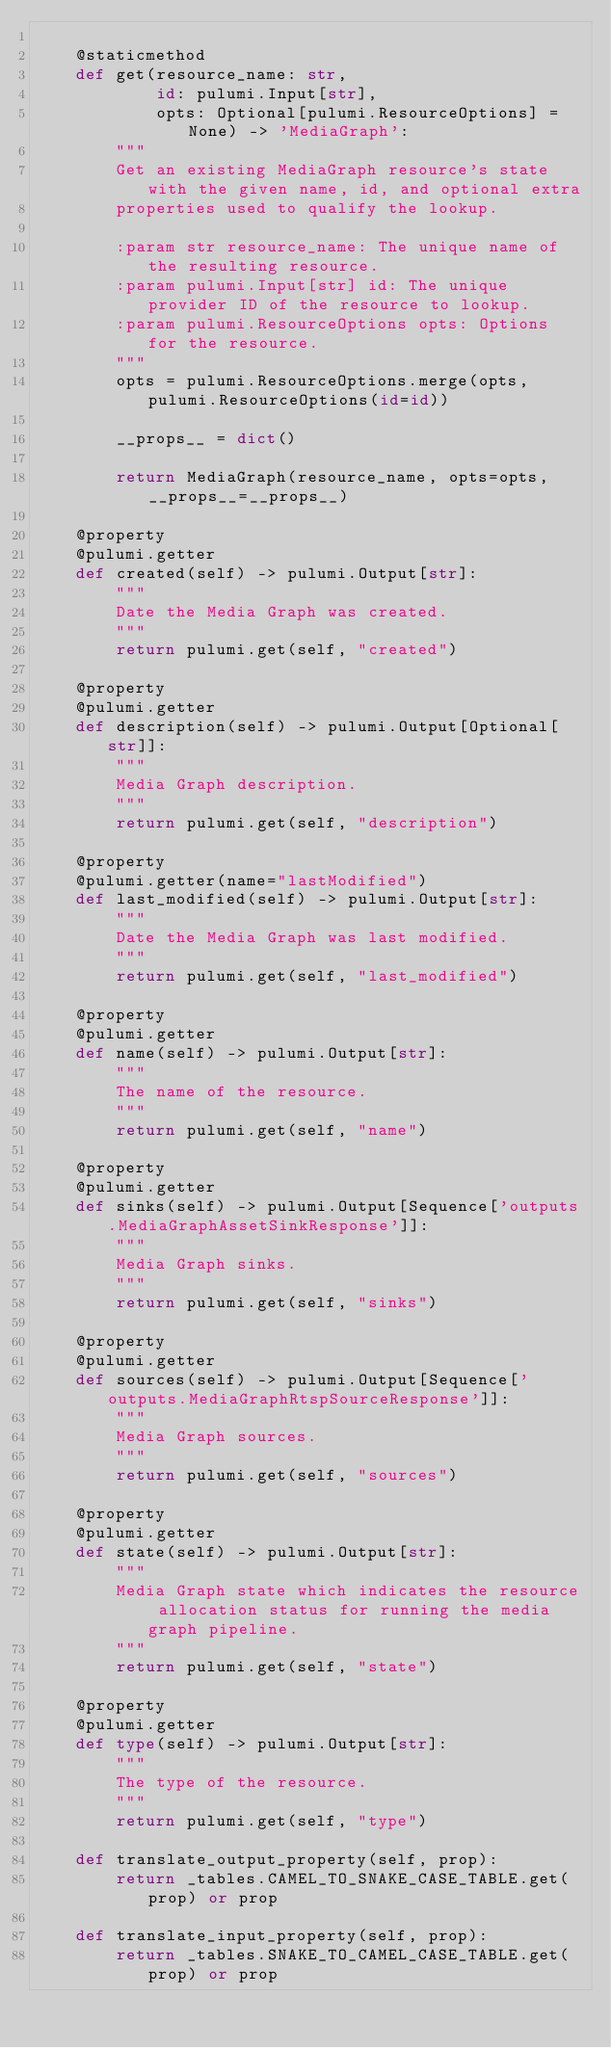Convert code to text. <code><loc_0><loc_0><loc_500><loc_500><_Python_>
    @staticmethod
    def get(resource_name: str,
            id: pulumi.Input[str],
            opts: Optional[pulumi.ResourceOptions] = None) -> 'MediaGraph':
        """
        Get an existing MediaGraph resource's state with the given name, id, and optional extra
        properties used to qualify the lookup.

        :param str resource_name: The unique name of the resulting resource.
        :param pulumi.Input[str] id: The unique provider ID of the resource to lookup.
        :param pulumi.ResourceOptions opts: Options for the resource.
        """
        opts = pulumi.ResourceOptions.merge(opts, pulumi.ResourceOptions(id=id))

        __props__ = dict()

        return MediaGraph(resource_name, opts=opts, __props__=__props__)

    @property
    @pulumi.getter
    def created(self) -> pulumi.Output[str]:
        """
        Date the Media Graph was created.
        """
        return pulumi.get(self, "created")

    @property
    @pulumi.getter
    def description(self) -> pulumi.Output[Optional[str]]:
        """
        Media Graph description.
        """
        return pulumi.get(self, "description")

    @property
    @pulumi.getter(name="lastModified")
    def last_modified(self) -> pulumi.Output[str]:
        """
        Date the Media Graph was last modified.
        """
        return pulumi.get(self, "last_modified")

    @property
    @pulumi.getter
    def name(self) -> pulumi.Output[str]:
        """
        The name of the resource.
        """
        return pulumi.get(self, "name")

    @property
    @pulumi.getter
    def sinks(self) -> pulumi.Output[Sequence['outputs.MediaGraphAssetSinkResponse']]:
        """
        Media Graph sinks.
        """
        return pulumi.get(self, "sinks")

    @property
    @pulumi.getter
    def sources(self) -> pulumi.Output[Sequence['outputs.MediaGraphRtspSourceResponse']]:
        """
        Media Graph sources.
        """
        return pulumi.get(self, "sources")

    @property
    @pulumi.getter
    def state(self) -> pulumi.Output[str]:
        """
        Media Graph state which indicates the resource allocation status for running the media graph pipeline.
        """
        return pulumi.get(self, "state")

    @property
    @pulumi.getter
    def type(self) -> pulumi.Output[str]:
        """
        The type of the resource.
        """
        return pulumi.get(self, "type")

    def translate_output_property(self, prop):
        return _tables.CAMEL_TO_SNAKE_CASE_TABLE.get(prop) or prop

    def translate_input_property(self, prop):
        return _tables.SNAKE_TO_CAMEL_CASE_TABLE.get(prop) or prop

</code> 